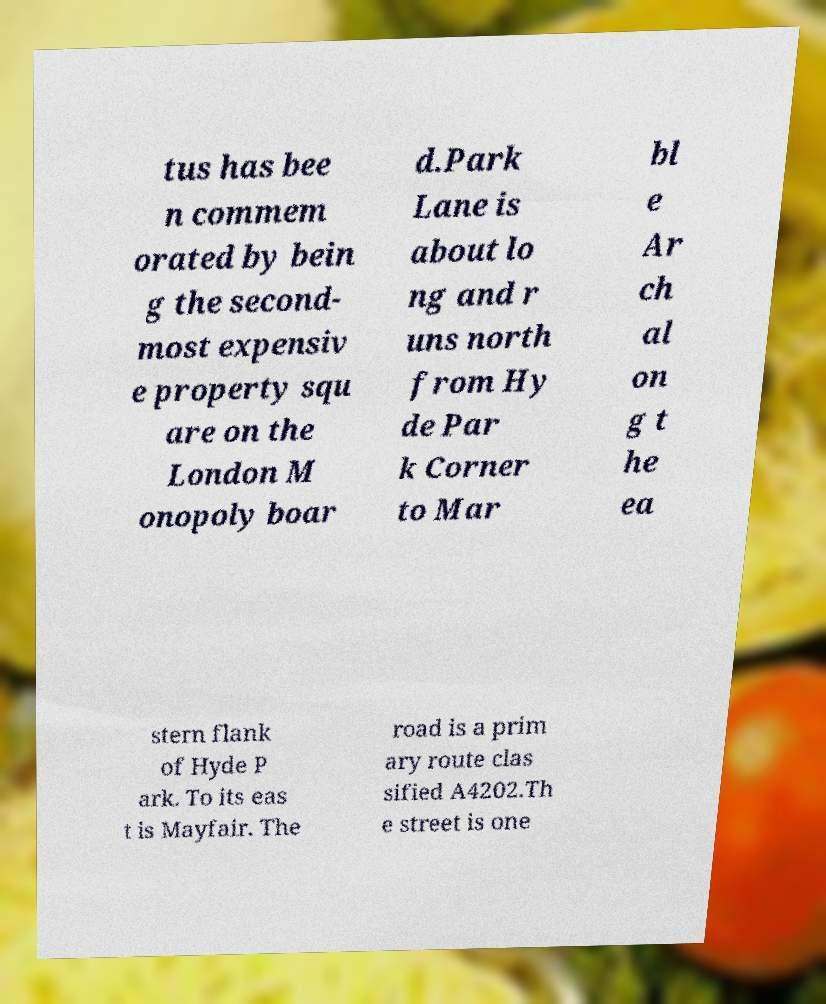Could you extract and type out the text from this image? tus has bee n commem orated by bein g the second- most expensiv e property squ are on the London M onopoly boar d.Park Lane is about lo ng and r uns north from Hy de Par k Corner to Mar bl e Ar ch al on g t he ea stern flank of Hyde P ark. To its eas t is Mayfair. The road is a prim ary route clas sified A4202.Th e street is one 